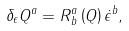Convert formula to latex. <formula><loc_0><loc_0><loc_500><loc_500>\delta _ { \epsilon } Q ^ { a } = R _ { \, b } ^ { a } \left ( Q \right ) \dot { \epsilon } ^ { b } ,</formula> 